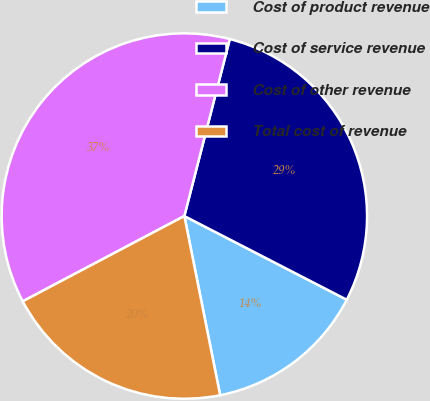Convert chart. <chart><loc_0><loc_0><loc_500><loc_500><pie_chart><fcel>Cost of product revenue<fcel>Cost of service revenue<fcel>Cost of other revenue<fcel>Total cost of revenue<nl><fcel>14.29%<fcel>28.57%<fcel>36.73%<fcel>20.41%<nl></chart> 